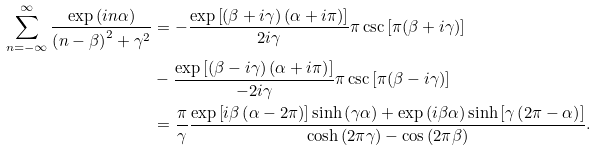Convert formula to latex. <formula><loc_0><loc_0><loc_500><loc_500>\sum _ { n = - \infty } ^ { \infty } \frac { \exp \left ( i n \alpha \right ) } { \left ( n - \beta \right ) ^ { 2 } + \gamma ^ { 2 } } & = - \frac { \exp \left [ ( \beta + i \gamma ) \left ( \alpha + i \pi \right ) \right ] } { 2 i \gamma } \pi \csc \left [ \pi ( \beta + i \gamma ) \right ] \\ & - \frac { \exp \left [ ( \beta - i \gamma ) \left ( \alpha + i \pi \right ) \right ] } { - 2 i \gamma } \pi \csc \left [ \pi ( \beta - i \gamma ) \right ] \\ & = \frac { \pi } { \gamma } \frac { \exp \left [ i \beta \left ( \alpha - 2 \pi \right ) \right ] \sinh \left ( \gamma \alpha \right ) + \exp \left ( i \beta \alpha \right ) \sinh \left [ \gamma \left ( 2 \pi - \alpha \right ) \right ] } { \cosh \left ( 2 \pi \gamma \right ) - \cos \left ( 2 \pi \beta \right ) } .</formula> 